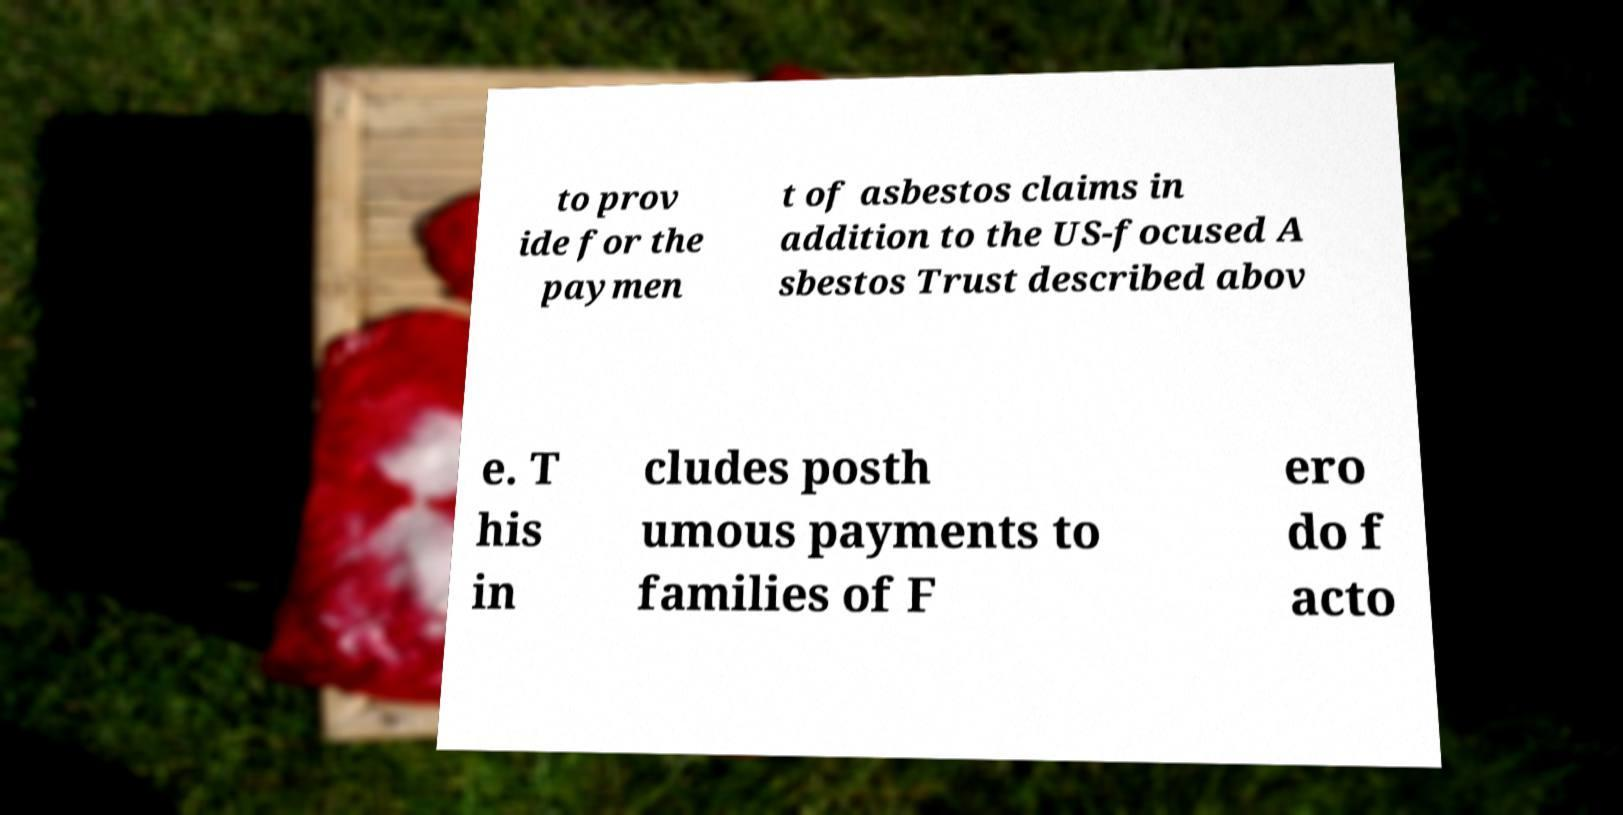I need the written content from this picture converted into text. Can you do that? to prov ide for the paymen t of asbestos claims in addition to the US-focused A sbestos Trust described abov e. T his in cludes posth umous payments to families of F ero do f acto 